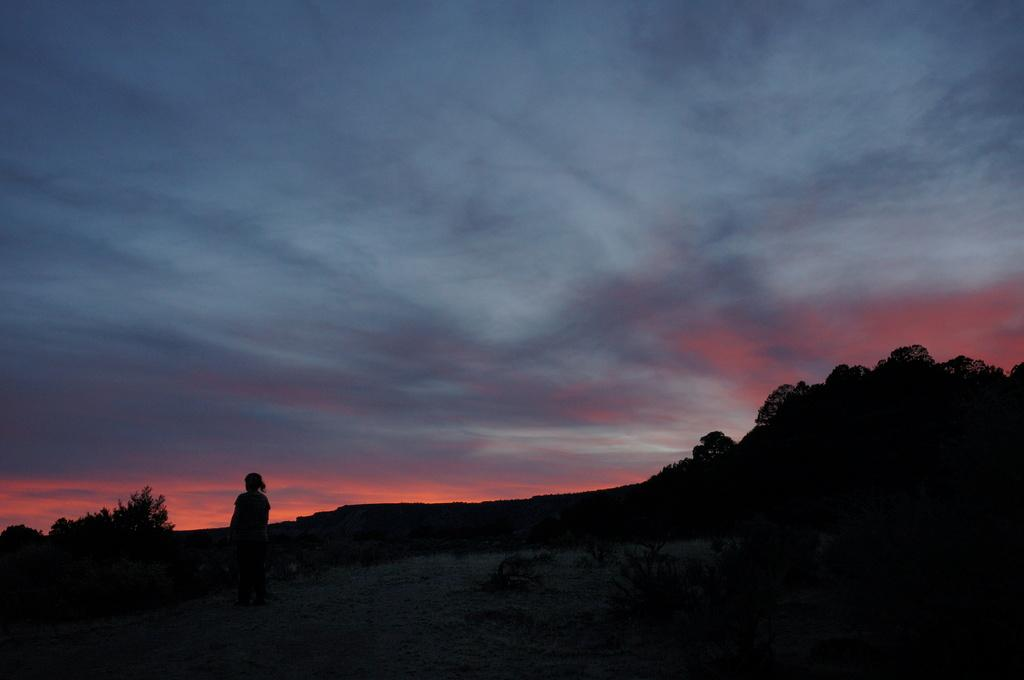What is the main subject of the image? There is a person standing on the ground in the image. What can be seen in the background of the image? Trees and the sky are visible in the image. What is the condition of the sky in the image? Clouds are present in the sky. How many crows are sitting on the box in the image? There is no box or crow present in the image. 